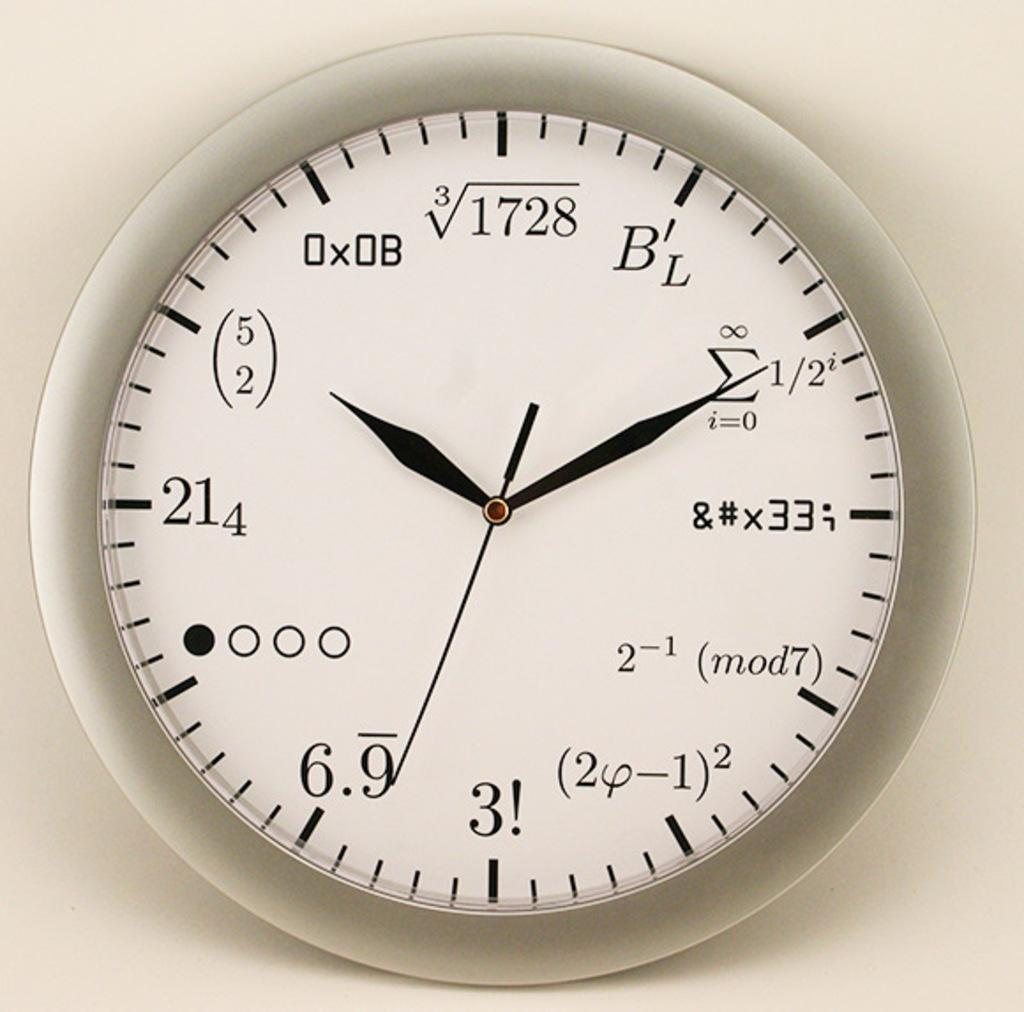Provide a one-sentence caption for the provided image. White, black, and silver clock with numbers and equations wrote on it. 